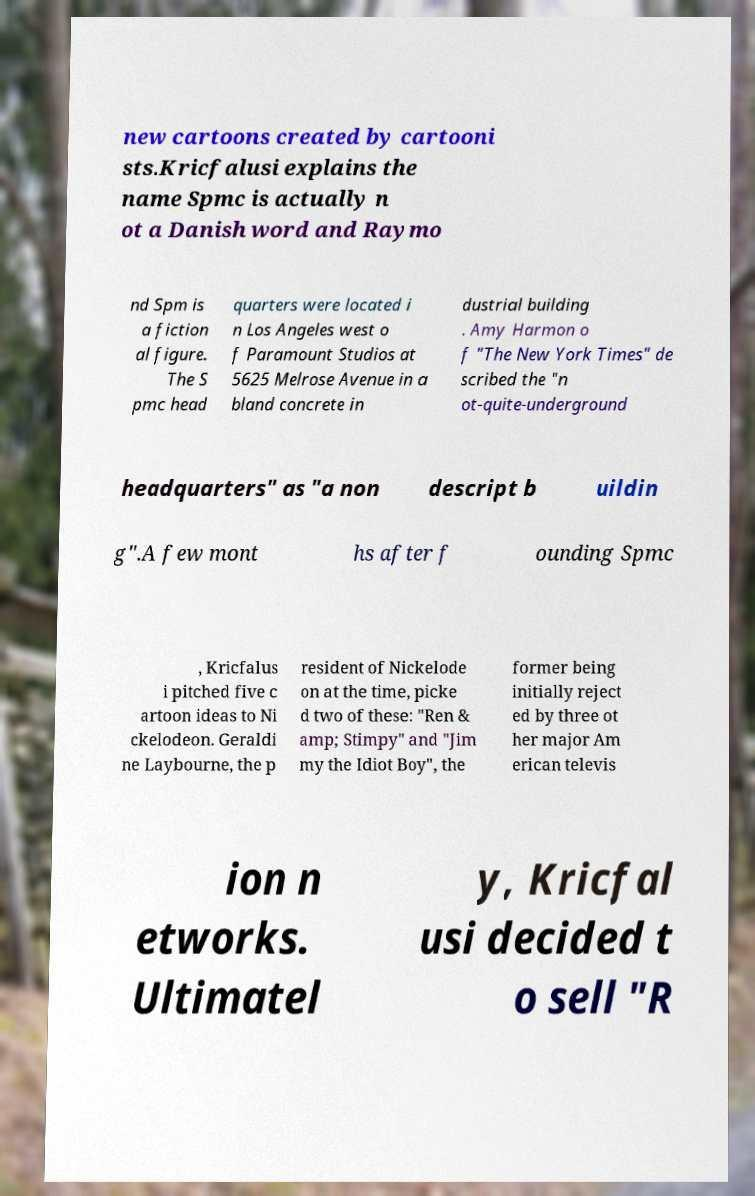I need the written content from this picture converted into text. Can you do that? new cartoons created by cartooni sts.Kricfalusi explains the name Spmc is actually n ot a Danish word and Raymo nd Spm is a fiction al figure. The S pmc head quarters were located i n Los Angeles west o f Paramount Studios at 5625 Melrose Avenue in a bland concrete in dustrial building . Amy Harmon o f "The New York Times" de scribed the "n ot-quite-underground headquarters" as "a non descript b uildin g".A few mont hs after f ounding Spmc , Kricfalus i pitched five c artoon ideas to Ni ckelodeon. Geraldi ne Laybourne, the p resident of Nickelode on at the time, picke d two of these: "Ren & amp; Stimpy" and "Jim my the Idiot Boy", the former being initially reject ed by three ot her major Am erican televis ion n etworks. Ultimatel y, Kricfal usi decided t o sell "R 